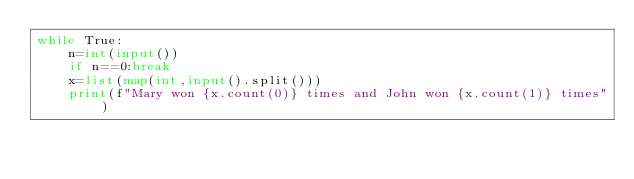Convert code to text. <code><loc_0><loc_0><loc_500><loc_500><_Python_>while True:
    n=int(input())
    if n==0:break
    x=list(map(int,input().split()))
    print(f"Mary won {x.count(0)} times and John won {x.count(1)} times")
</code> 